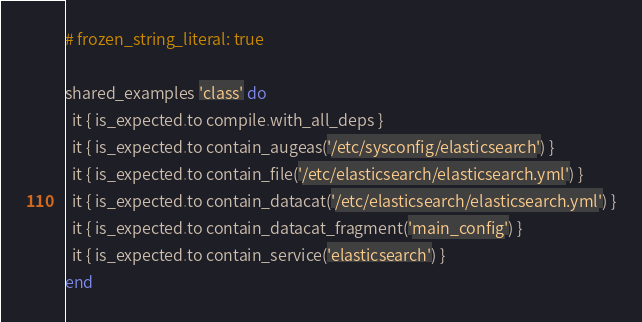<code> <loc_0><loc_0><loc_500><loc_500><_Ruby_># frozen_string_literal: true

shared_examples 'class' do
  it { is_expected.to compile.with_all_deps }
  it { is_expected.to contain_augeas('/etc/sysconfig/elasticsearch') }
  it { is_expected.to contain_file('/etc/elasticsearch/elasticsearch.yml') }
  it { is_expected.to contain_datacat('/etc/elasticsearch/elasticsearch.yml') }
  it { is_expected.to contain_datacat_fragment('main_config') }
  it { is_expected.to contain_service('elasticsearch') }
end
</code> 